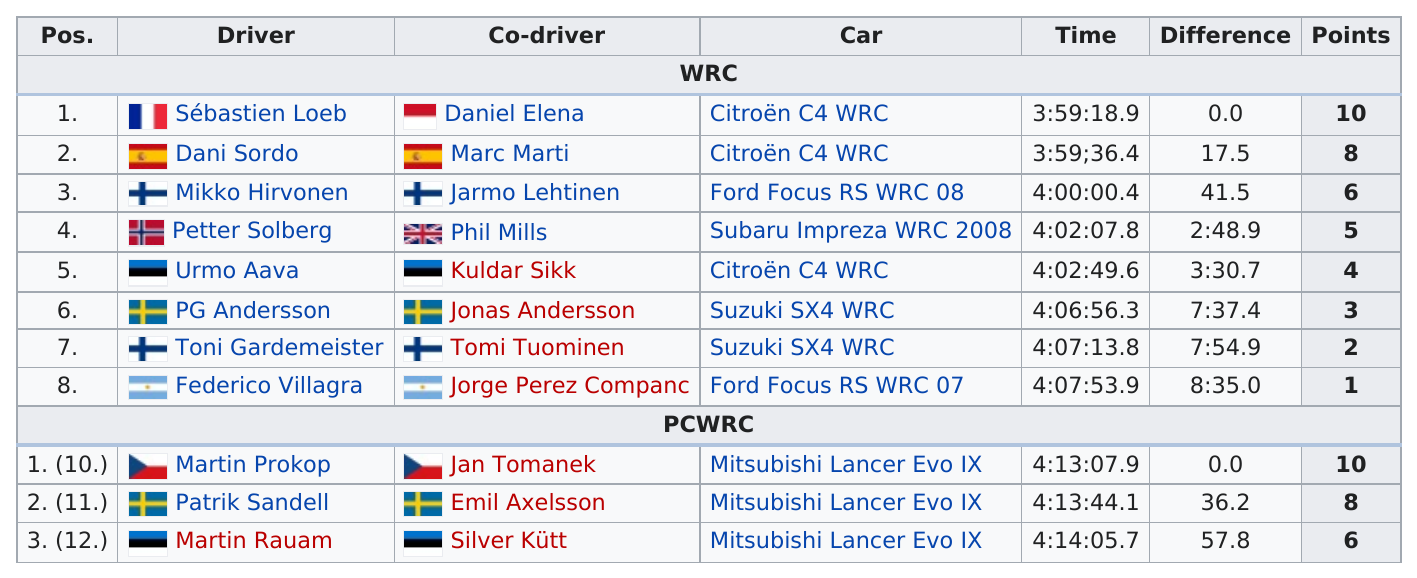Mention a couple of crucial points in this snapshot. The Citroën C4 WRC had the shortest time in the WRC. Patrik Sandell, the driver, was the only one to score 8 points while driving a Mitsubishi. The Suzuki SX4 WRC car was used a total of two times. Dani Sordo and Marc Marti finished at 3:59 with 8 points. Petter Solberg was faster than Gardemeister in the 2008 New Zealand Rally. 